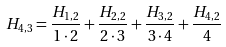Convert formula to latex. <formula><loc_0><loc_0><loc_500><loc_500>H _ { 4 , 3 } = { \frac { H _ { 1 , 2 } } { 1 \cdot 2 } } + { \frac { H _ { 2 , 2 } } { 2 \cdot 3 } } + { \frac { H _ { 3 , 2 } } { 3 \cdot 4 } } + { \frac { H _ { 4 , 2 } } { 4 } }</formula> 